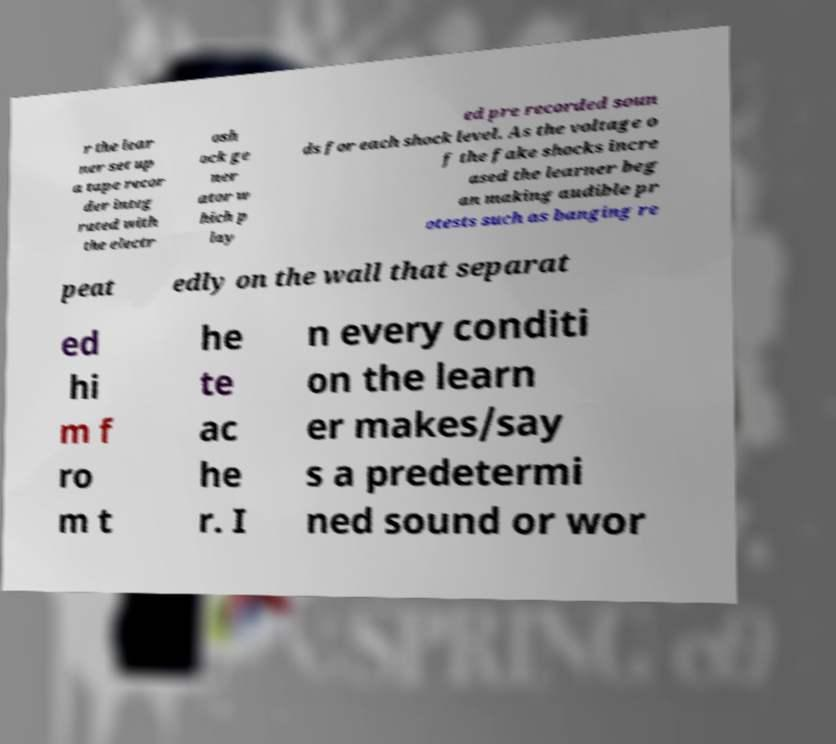Could you assist in decoding the text presented in this image and type it out clearly? r the lear ner set up a tape recor der integ rated with the electr osh ock ge ner ator w hich p lay ed pre recorded soun ds for each shock level. As the voltage o f the fake shocks incre ased the learner beg an making audible pr otests such as banging re peat edly on the wall that separat ed hi m f ro m t he te ac he r. I n every conditi on the learn er makes/say s a predetermi ned sound or wor 